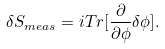Convert formula to latex. <formula><loc_0><loc_0><loc_500><loc_500>\delta S _ { m e a s } = i T r [ \frac { \partial } { \partial \phi } \delta \phi ] .</formula> 